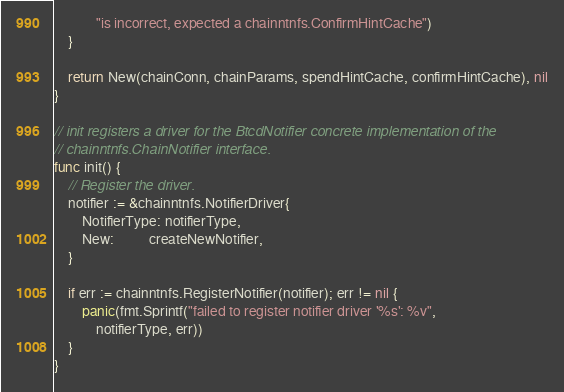Convert code to text. <code><loc_0><loc_0><loc_500><loc_500><_Go_>			"is incorrect, expected a chainntnfs.ConfirmHintCache")
	}

	return New(chainConn, chainParams, spendHintCache, confirmHintCache), nil
}

// init registers a driver for the BtcdNotifier concrete implementation of the
// chainntnfs.ChainNotifier interface.
func init() {
	// Register the driver.
	notifier := &chainntnfs.NotifierDriver{
		NotifierType: notifierType,
		New:          createNewNotifier,
	}

	if err := chainntnfs.RegisterNotifier(notifier); err != nil {
		panic(fmt.Sprintf("failed to register notifier driver '%s': %v",
			notifierType, err))
	}
}
</code> 